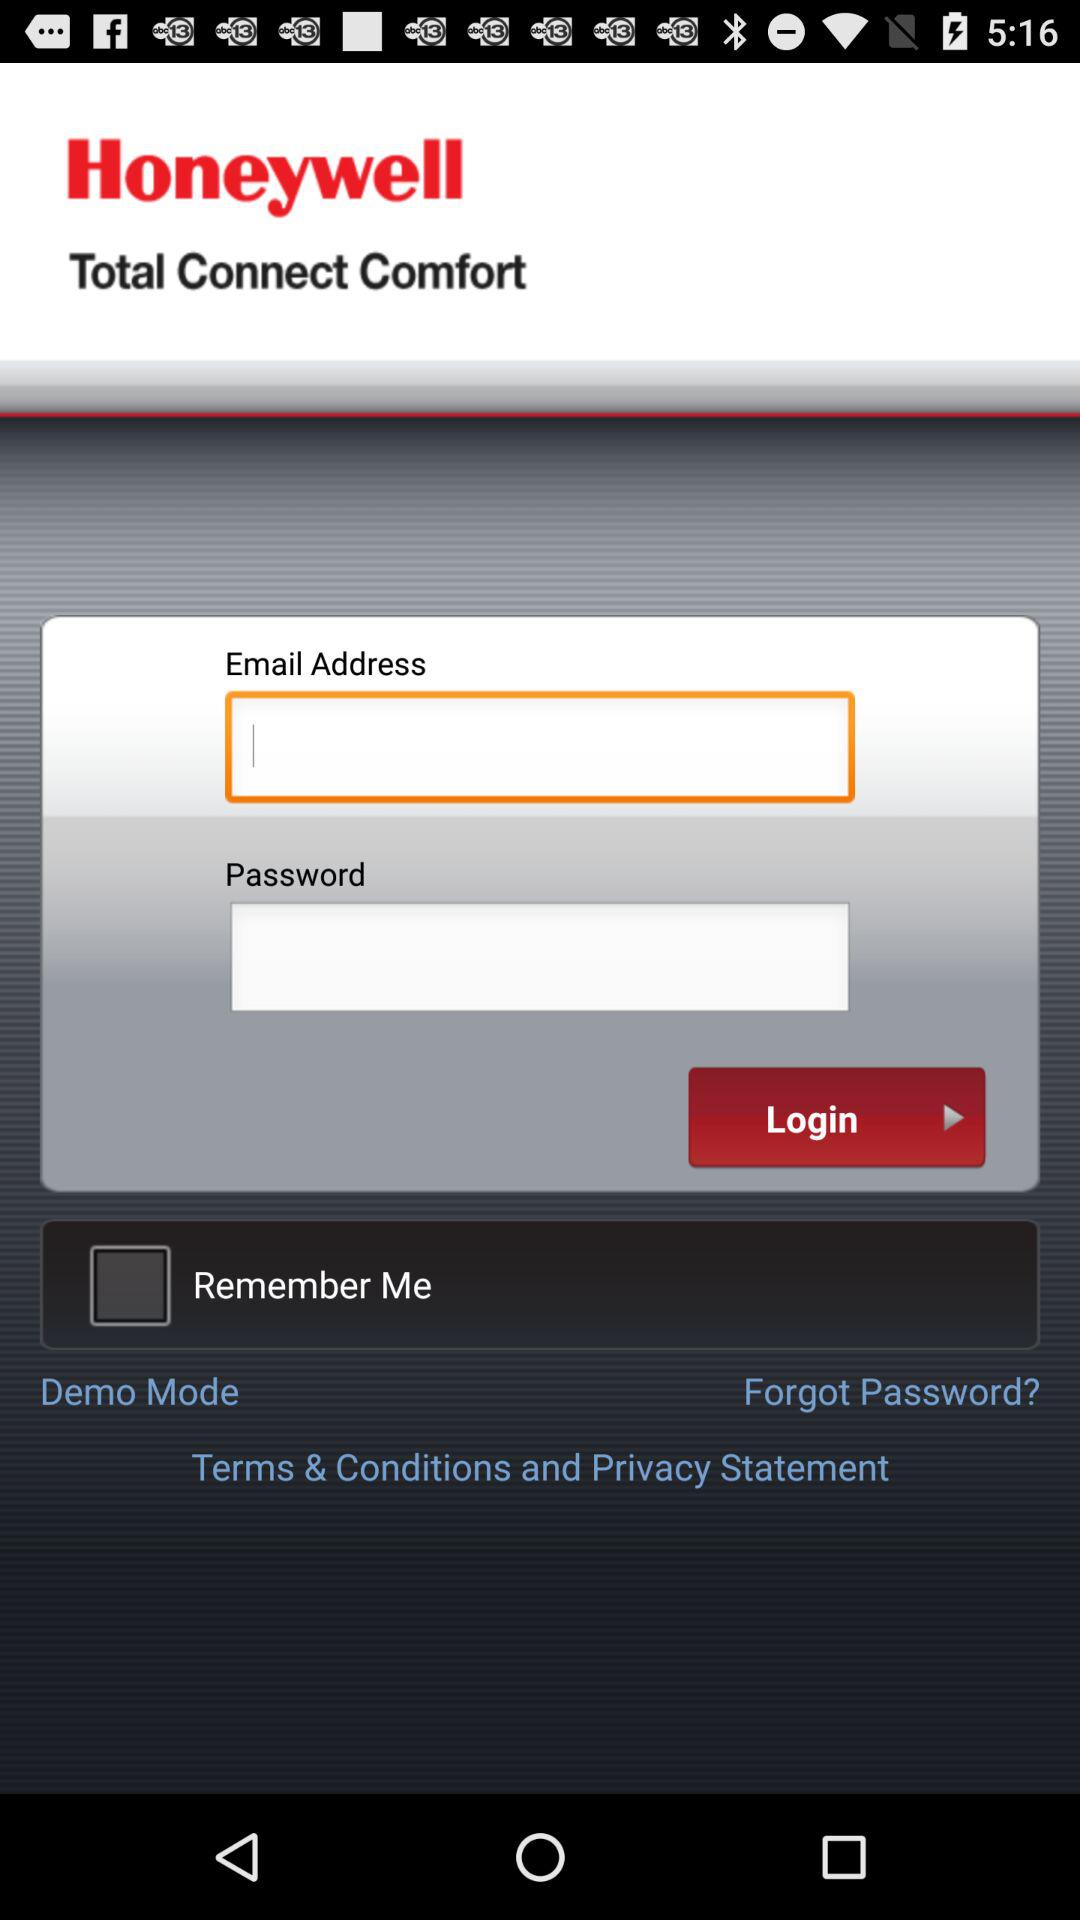What is the name of the application? The name of the application is "Total Connect Comfort". 